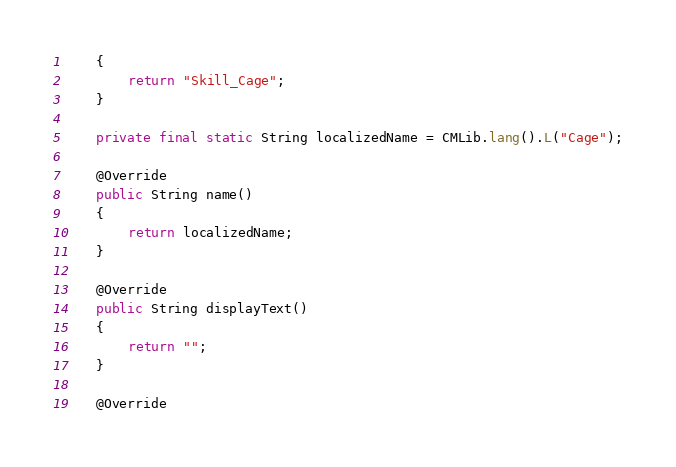<code> <loc_0><loc_0><loc_500><loc_500><_Java_>	{
		return "Skill_Cage";
	}

	private final static String localizedName = CMLib.lang().L("Cage");

	@Override
	public String name()
	{
		return localizedName;
	}

	@Override
	public String displayText()
	{
		return "";
	}

	@Override</code> 